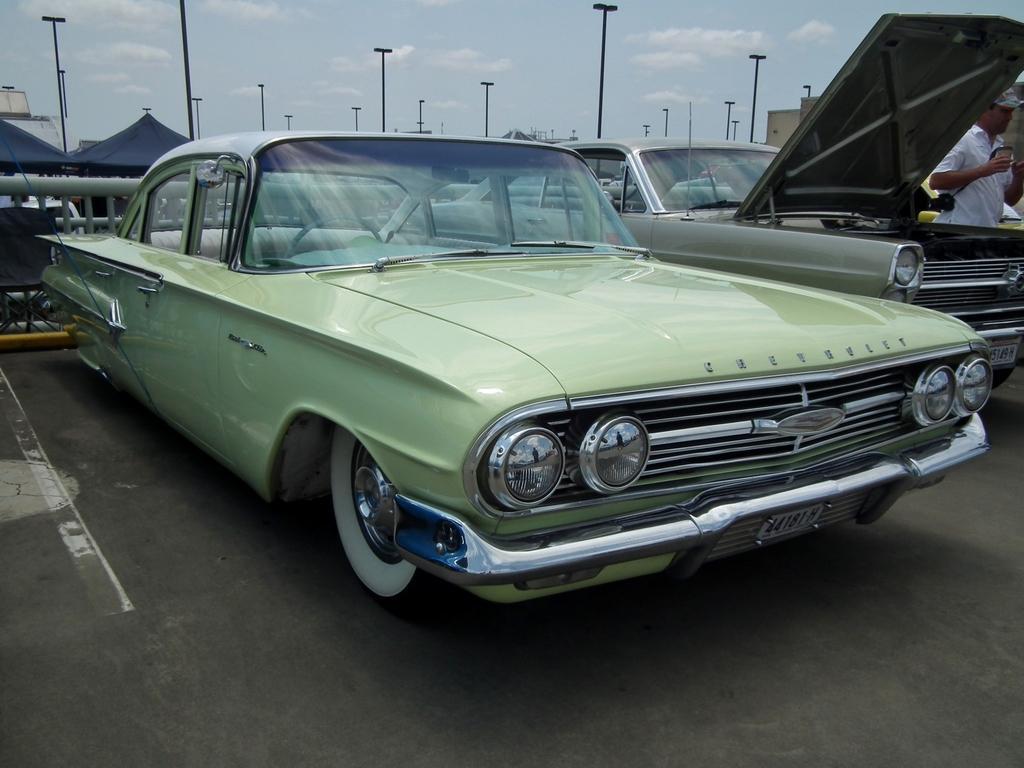Please provide a concise description of this image. At the bottom, we see the road. In the middle, we see the cars parked on the road. On the right side, we see a man in the white T-shirt is standing. He is holding something in his hands. On the left side, we see a black chair and the railing. In the background, we see the poles, black color tents and the buildings. At the top, we see the sky and the clouds. 